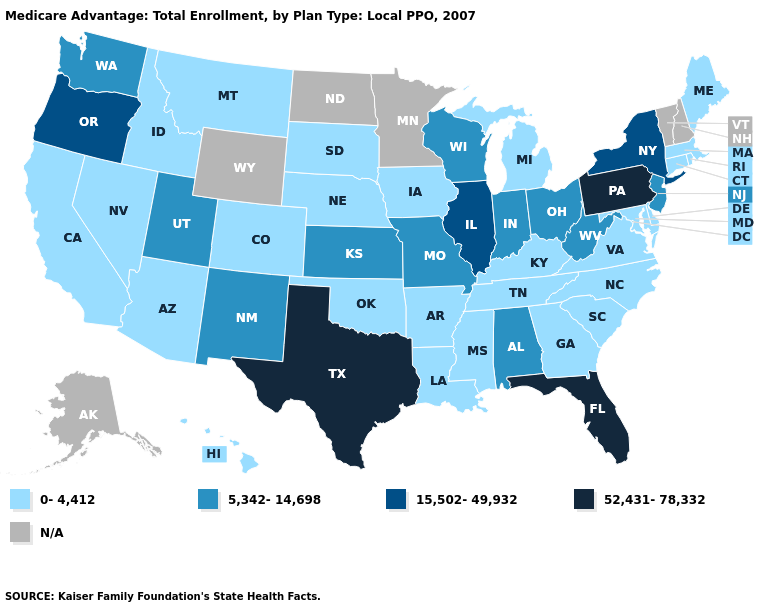What is the value of Delaware?
Keep it brief. 0-4,412. Does Alabama have the highest value in the South?
Concise answer only. No. Among the states that border Oregon , does Washington have the highest value?
Concise answer only. Yes. What is the lowest value in the MidWest?
Write a very short answer. 0-4,412. Which states have the highest value in the USA?
Short answer required. Florida, Pennsylvania, Texas. What is the value of Alaska?
Keep it brief. N/A. Name the states that have a value in the range 0-4,412?
Answer briefly. Arkansas, Arizona, California, Colorado, Connecticut, Delaware, Georgia, Hawaii, Iowa, Idaho, Kentucky, Louisiana, Massachusetts, Maryland, Maine, Michigan, Mississippi, Montana, North Carolina, Nebraska, Nevada, Oklahoma, Rhode Island, South Carolina, South Dakota, Tennessee, Virginia. What is the value of Wisconsin?
Short answer required. 5,342-14,698. Does Pennsylvania have the highest value in the USA?
Write a very short answer. Yes. Name the states that have a value in the range 0-4,412?
Short answer required. Arkansas, Arizona, California, Colorado, Connecticut, Delaware, Georgia, Hawaii, Iowa, Idaho, Kentucky, Louisiana, Massachusetts, Maryland, Maine, Michigan, Mississippi, Montana, North Carolina, Nebraska, Nevada, Oklahoma, Rhode Island, South Carolina, South Dakota, Tennessee, Virginia. Does Utah have the lowest value in the USA?
Answer briefly. No. What is the highest value in states that border Arizona?
Keep it brief. 5,342-14,698. What is the highest value in the USA?
Give a very brief answer. 52,431-78,332. 